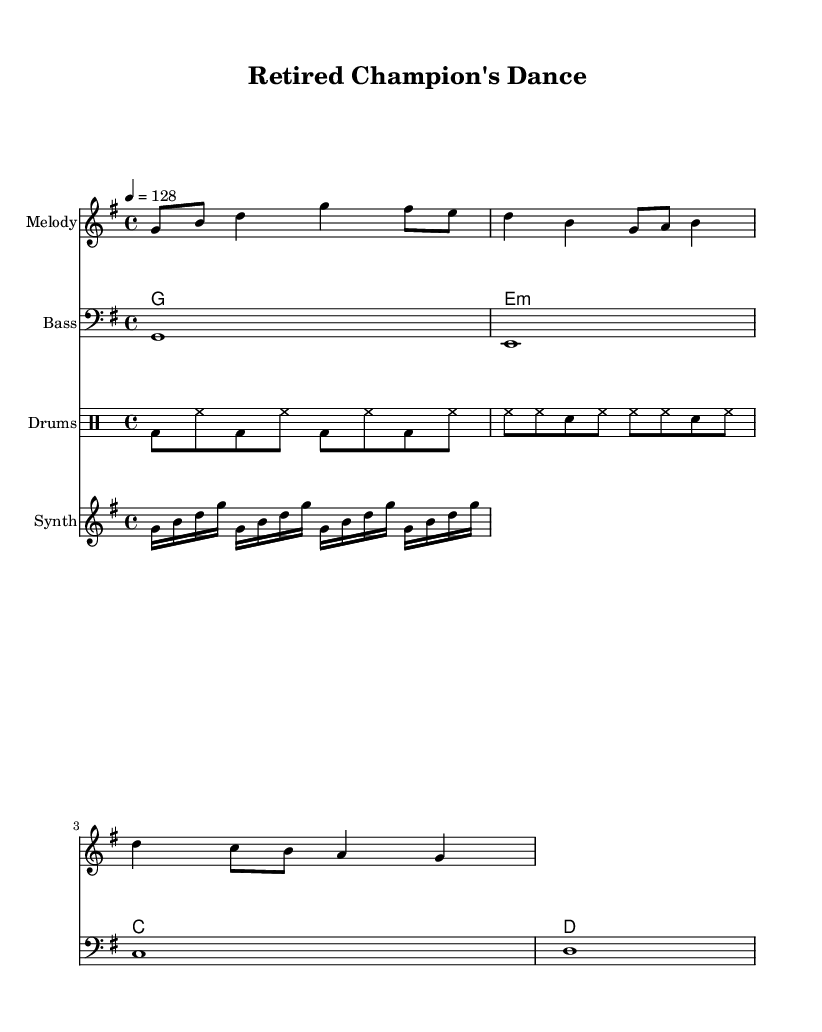What is the key signature of this music? The key signature shows that there is one sharp (F#), indicating that the key is G major.
Answer: G major What is the time signature of this piece? The time signature is indicated at the beginning of the staff with a '4/4', which means there are four beats in each measure and a quarter note receives one beat.
Answer: 4/4 What is the tempo marking for this piece? The tempo marking indicates that the piece should be played at 128 beats per minute, stated as "4 = 128" at the beginning of the score.
Answer: 128 How many measures are in the melody section? By counting the distinct musical phrases separated by bars, we can see there are four measures in the melody section provided in the score.
Answer: 4 What type of chord is used in the second measure? The chord shown is an E minor, which is identified in the "ChordNames" section as "e1:m" indicating that this particular chord is a minor chord.
Answer: E minor What type of drums are specified in this piece? The score uses a 'bd' for bass drum and 'hh' for hi-hat, reflecting common K-Pop drum patterns, and these are notated in the DrumStaff section.
Answer: Bass drum and hi-hat How many different instruments are indicated in this score? The score includes four distinct instrumental parts: Melody, Bass, Drums, and Synth, making a total of four different instruments being used.
Answer: 4 